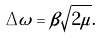<formula> <loc_0><loc_0><loc_500><loc_500>\Delta \omega = \beta \sqrt { 2 \mu } .</formula> 